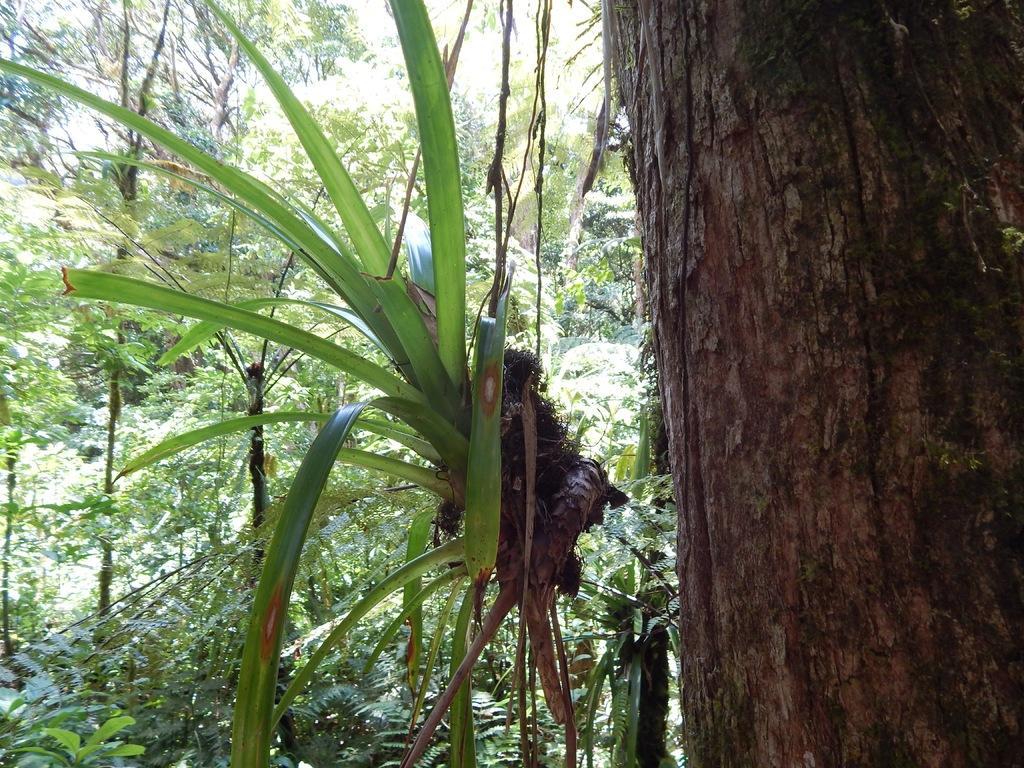Could you give a brief overview of what you see in this image? In this image we can see there are trees and tree trunk. 